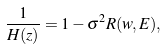<formula> <loc_0><loc_0><loc_500><loc_500>\frac { 1 } { H ( z ) } = 1 - \sigma ^ { 2 } R ( w , E ) ,</formula> 